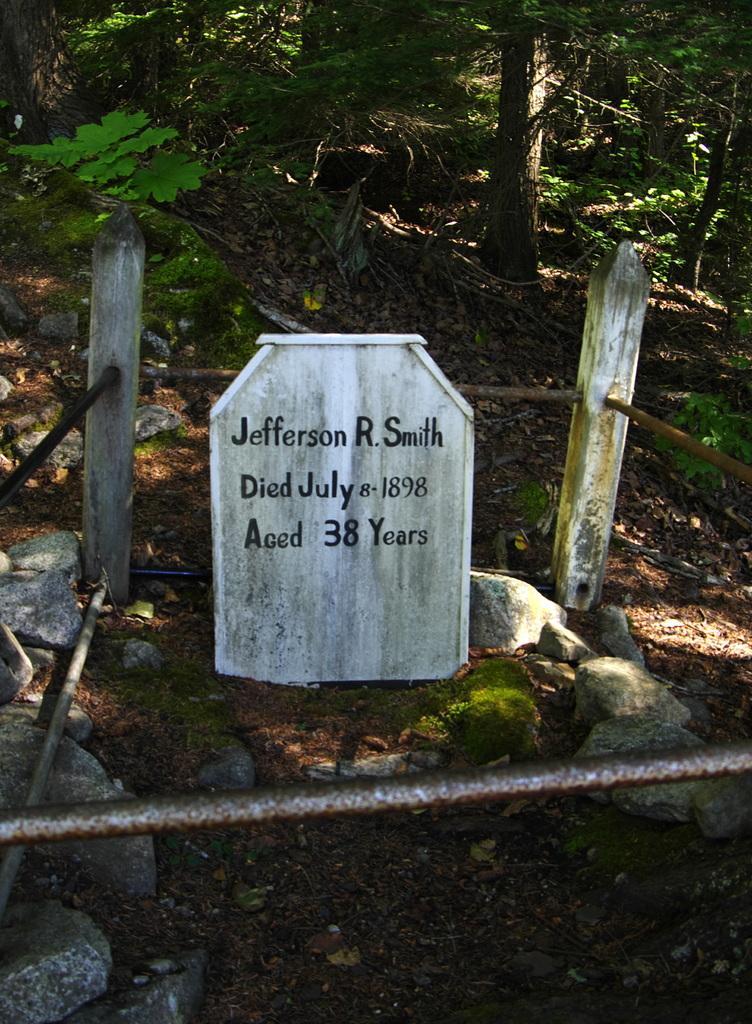Could you give a brief overview of what you see in this image? In this image I can see a gravestone. On the stone I can see something written on it. Here I can see poles and metal rods. In the background I can see trees. 